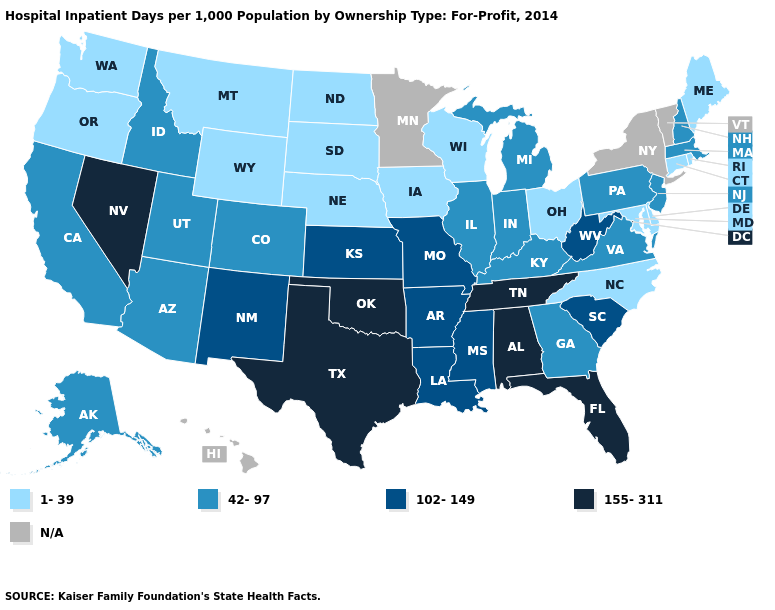What is the value of Missouri?
Be succinct. 102-149. Name the states that have a value in the range 102-149?
Concise answer only. Arkansas, Kansas, Louisiana, Mississippi, Missouri, New Mexico, South Carolina, West Virginia. What is the value of North Dakota?
Keep it brief. 1-39. Is the legend a continuous bar?
Short answer required. No. What is the value of Arizona?
Write a very short answer. 42-97. Name the states that have a value in the range 42-97?
Keep it brief. Alaska, Arizona, California, Colorado, Georgia, Idaho, Illinois, Indiana, Kentucky, Massachusetts, Michigan, New Hampshire, New Jersey, Pennsylvania, Utah, Virginia. Does Maryland have the lowest value in the South?
Short answer required. Yes. Name the states that have a value in the range N/A?
Give a very brief answer. Hawaii, Minnesota, New York, Vermont. What is the value of South Carolina?
Keep it brief. 102-149. Which states have the lowest value in the MidWest?
Quick response, please. Iowa, Nebraska, North Dakota, Ohio, South Dakota, Wisconsin. What is the lowest value in states that border Minnesota?
Keep it brief. 1-39. Is the legend a continuous bar?
Give a very brief answer. No. Which states have the highest value in the USA?
Keep it brief. Alabama, Florida, Nevada, Oklahoma, Tennessee, Texas. What is the value of Michigan?
Short answer required. 42-97. Which states have the lowest value in the USA?
Keep it brief. Connecticut, Delaware, Iowa, Maine, Maryland, Montana, Nebraska, North Carolina, North Dakota, Ohio, Oregon, Rhode Island, South Dakota, Washington, Wisconsin, Wyoming. 